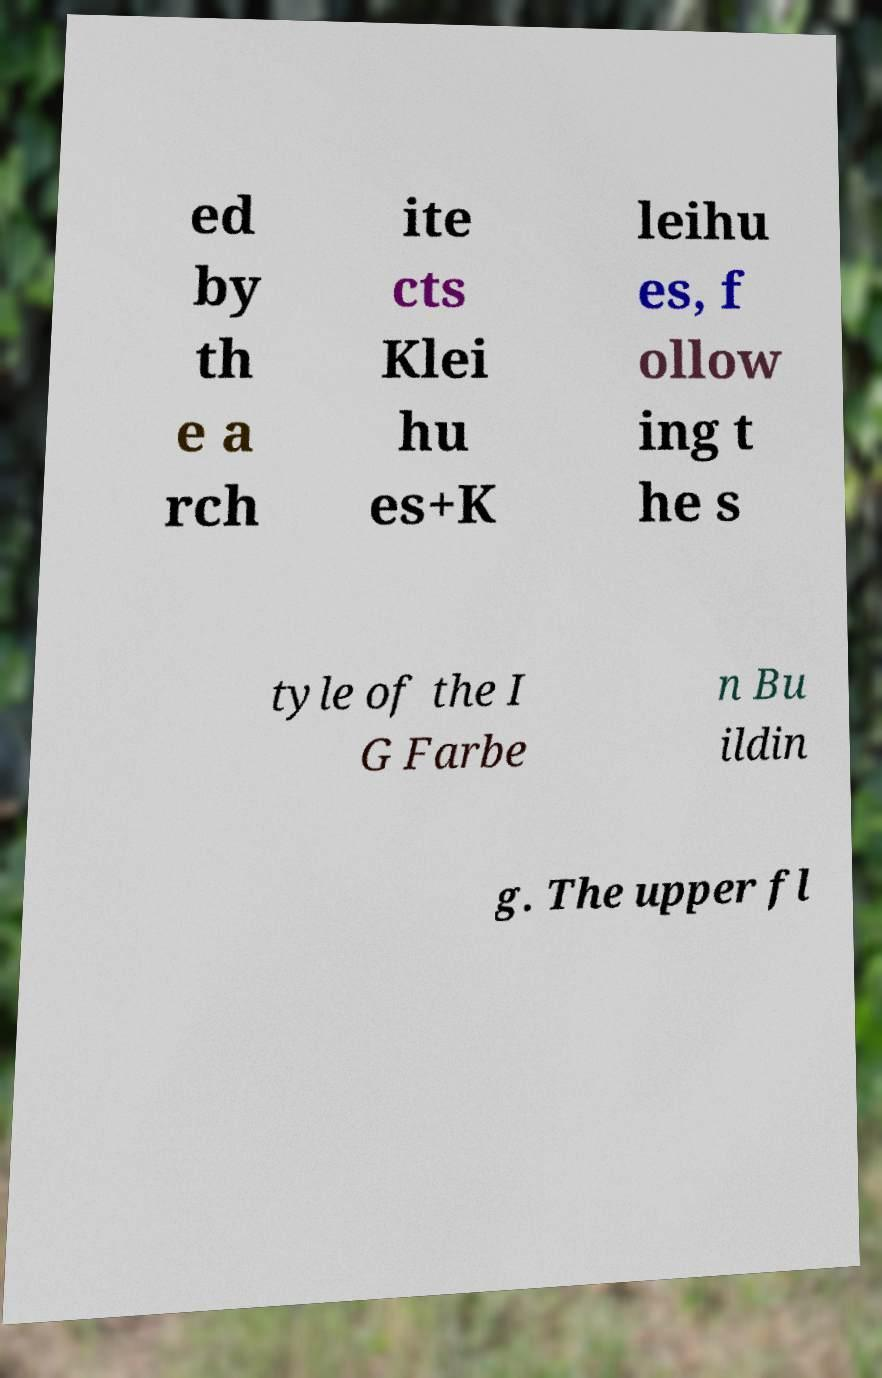I need the written content from this picture converted into text. Can you do that? ed by th e a rch ite cts Klei hu es+K leihu es, f ollow ing t he s tyle of the I G Farbe n Bu ildin g. The upper fl 